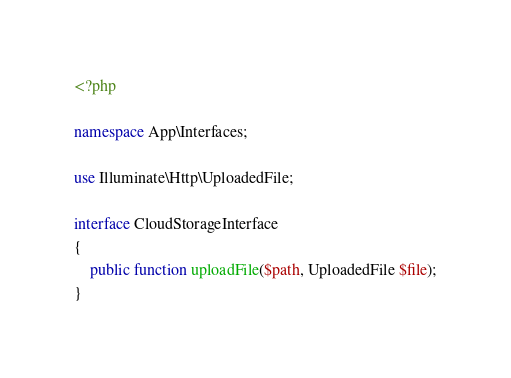Convert code to text. <code><loc_0><loc_0><loc_500><loc_500><_PHP_><?php

namespace App\Interfaces;

use Illuminate\Http\UploadedFile;

interface CloudStorageInterface
{
    public function uploadFile($path, UploadedFile $file);
}
</code> 